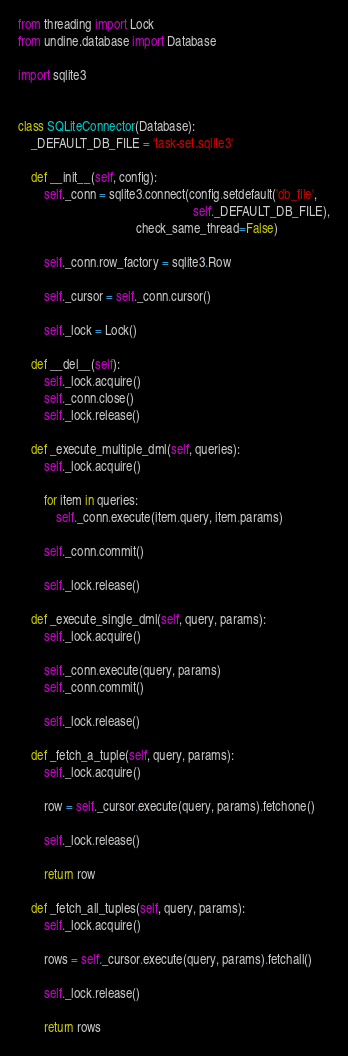Convert code to text. <code><loc_0><loc_0><loc_500><loc_500><_Python_>from threading import Lock
from undine.database import Database

import sqlite3


class SQLiteConnector(Database):
    _DEFAULT_DB_FILE = 'task-set.sqlite3'

    def __init__(self, config):
        self._conn = sqlite3.connect(config.setdefault('db_file',
                                                       self._DEFAULT_DB_FILE),
                                     check_same_thread=False)

        self._conn.row_factory = sqlite3.Row

        self._cursor = self._conn.cursor()

        self._lock = Lock()

    def __del__(self):
        self._lock.acquire()
        self._conn.close()
        self._lock.release()

    def _execute_multiple_dml(self, queries):
        self._lock.acquire()

        for item in queries:
            self._conn.execute(item.query, item.params)

        self._conn.commit()

        self._lock.release()

    def _execute_single_dml(self, query, params):
        self._lock.acquire()

        self._conn.execute(query, params)
        self._conn.commit()

        self._lock.release()

    def _fetch_a_tuple(self, query, params):
        self._lock.acquire()

        row = self._cursor.execute(query, params).fetchone()

        self._lock.release()

        return row

    def _fetch_all_tuples(self, query, params):
        self._lock.acquire()

        rows = self._cursor.execute(query, params).fetchall()

        self._lock.release()

        return rows
</code> 